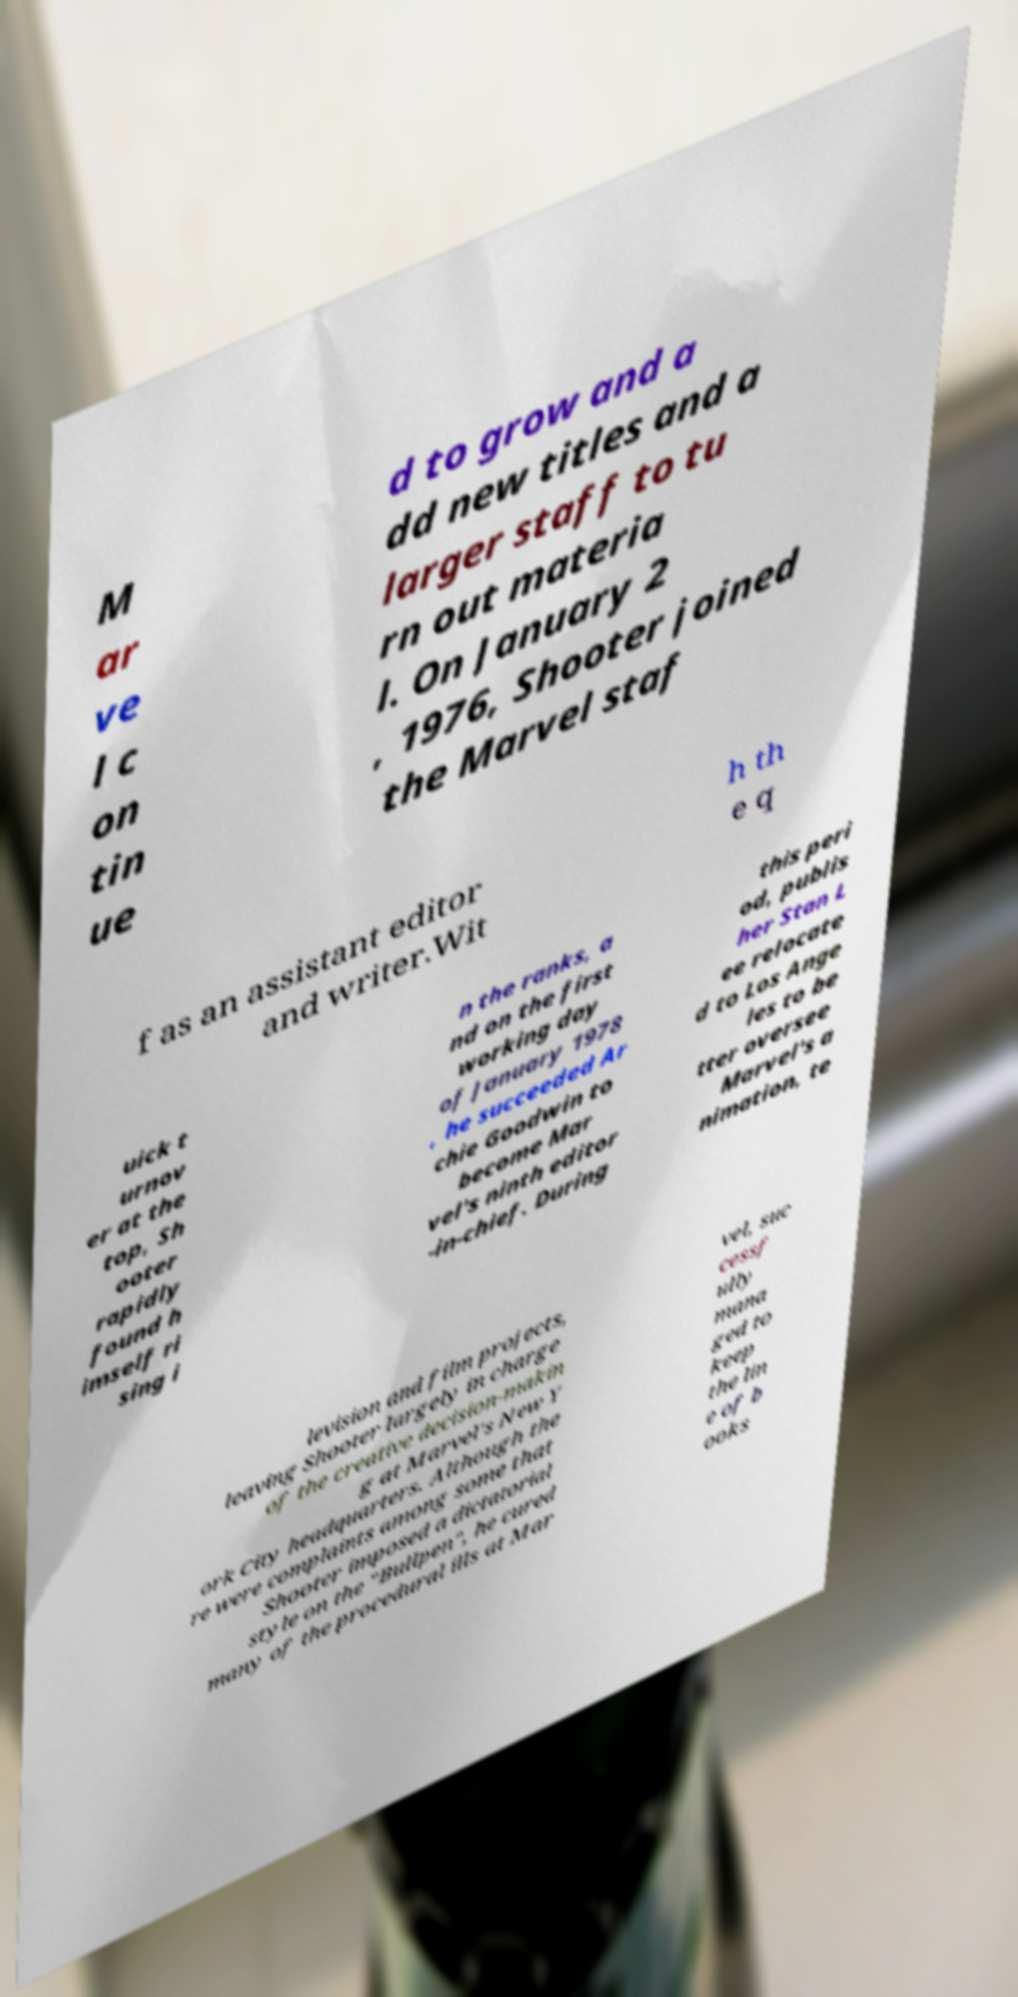I need the written content from this picture converted into text. Can you do that? M ar ve l c on tin ue d to grow and a dd new titles and a larger staff to tu rn out materia l. On January 2 , 1976, Shooter joined the Marvel staf f as an assistant editor and writer.Wit h th e q uick t urnov er at the top, Sh ooter rapidly found h imself ri sing i n the ranks, a nd on the first working day of January 1978 , he succeeded Ar chie Goodwin to become Mar vel's ninth editor -in-chief. During this peri od, publis her Stan L ee relocate d to Los Ange les to be tter oversee Marvel's a nimation, te levision and film projects, leaving Shooter largely in charge of the creative decision-makin g at Marvel's New Y ork City headquarters. Although the re were complaints among some that Shooter imposed a dictatorial style on the "Bullpen", he cured many of the procedural ills at Mar vel, suc cessf ully mana ged to keep the lin e of b ooks 